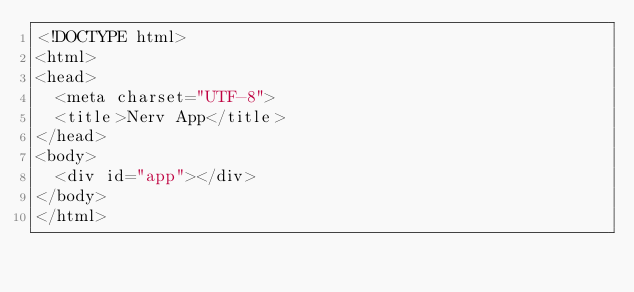<code> <loc_0><loc_0><loc_500><loc_500><_HTML_><!DOCTYPE html>
<html>
<head>
  <meta charset="UTF-8">
  <title>Nerv App</title>
</head>
<body>
  <div id="app"></div>
</body>
</html></code> 